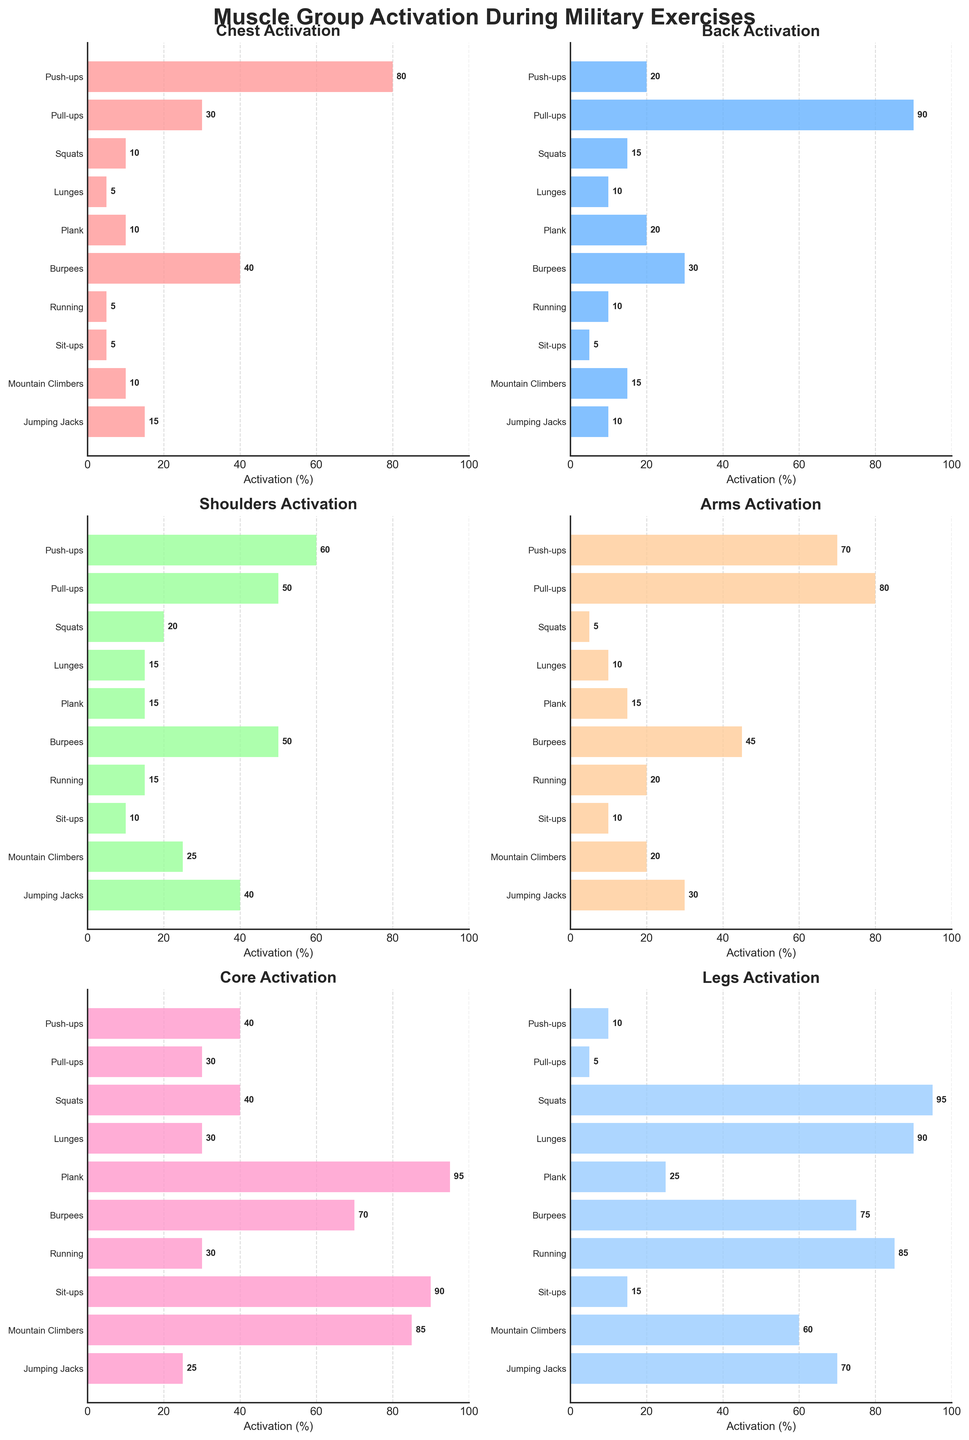What is the title of the figure? The title of the figure is displayed at the top of the plot. It gives an overall summary of what the figure represents.
Answer: Muscle Group Activation During Military Exercises Which exercise has the highest activation in the core muscle group? Look at the subplot for 'Core Activation' and identify the bar with the highest value. Plank has the highest activation.
Answer: Plank What's the average leg activation for Push-ups, Pull-ups, and Squats? Add the leg activation percentages for Push-ups (10), Pull-ups (5), and Squats (95), then divide by 3. (10 + 5 + 95) / 3 = 110 / 3 = 36.67
Answer: 36.67 How does arm activation compare between Push-ups and Burpees? Look at the 'Arms Activation' subplot. Push-ups have 70% activation, and Burpees have 45% activation. 70% is greater than 45%.
Answer: Push-ups have higher activation Which exercise has the lowest activation in the back muscle group? Look at the 'Back Activation' subplot and find the bar with the smallest value. Sit-ups have the lowest activation with 5%.
Answer: Sit-ups List the exercises where the chest muscle activation is 10% or lower. Look at the 'Chest Activation' subplot and identify exercises with bars at or below 10%. Squats, Lunges, Running, and Sit-ups have 10% or lower chest activation.
Answer: Squats, Lunges, Running, Sit-ups What is the total shoulder activation for Plank and Pull-ups combined? Add the shoulder activation for Plank (15) and Pull-ups (50). 15 + 50 = 65
Answer: 65 Which exercise activates more legs: Mountain Climbers or Jumping Jacks? Refer to the 'Legs Activation' subplot and compare the bars for Mountain Climbers (60) and Jumping Jacks (70). Jumping Jacks have higher activation.
Answer: Jumping Jacks Display the muscle group that has the highest activation during Burpees. Look at the 'Burpees' row across each subplot to find the highest value, which is 70% in Core.
Answer: Core How many exercises have more than 80% activation in at least one muscle group? Count the exercises across all subplots with bars exceeding 80% activation. Push-ups (Chest), Pull-ups (Back), Squats (Legs), Plank (Core), and Mountain Climbers (Core) are the exercises meeting the criteria. There are 5 exercises.
Answer: 5 